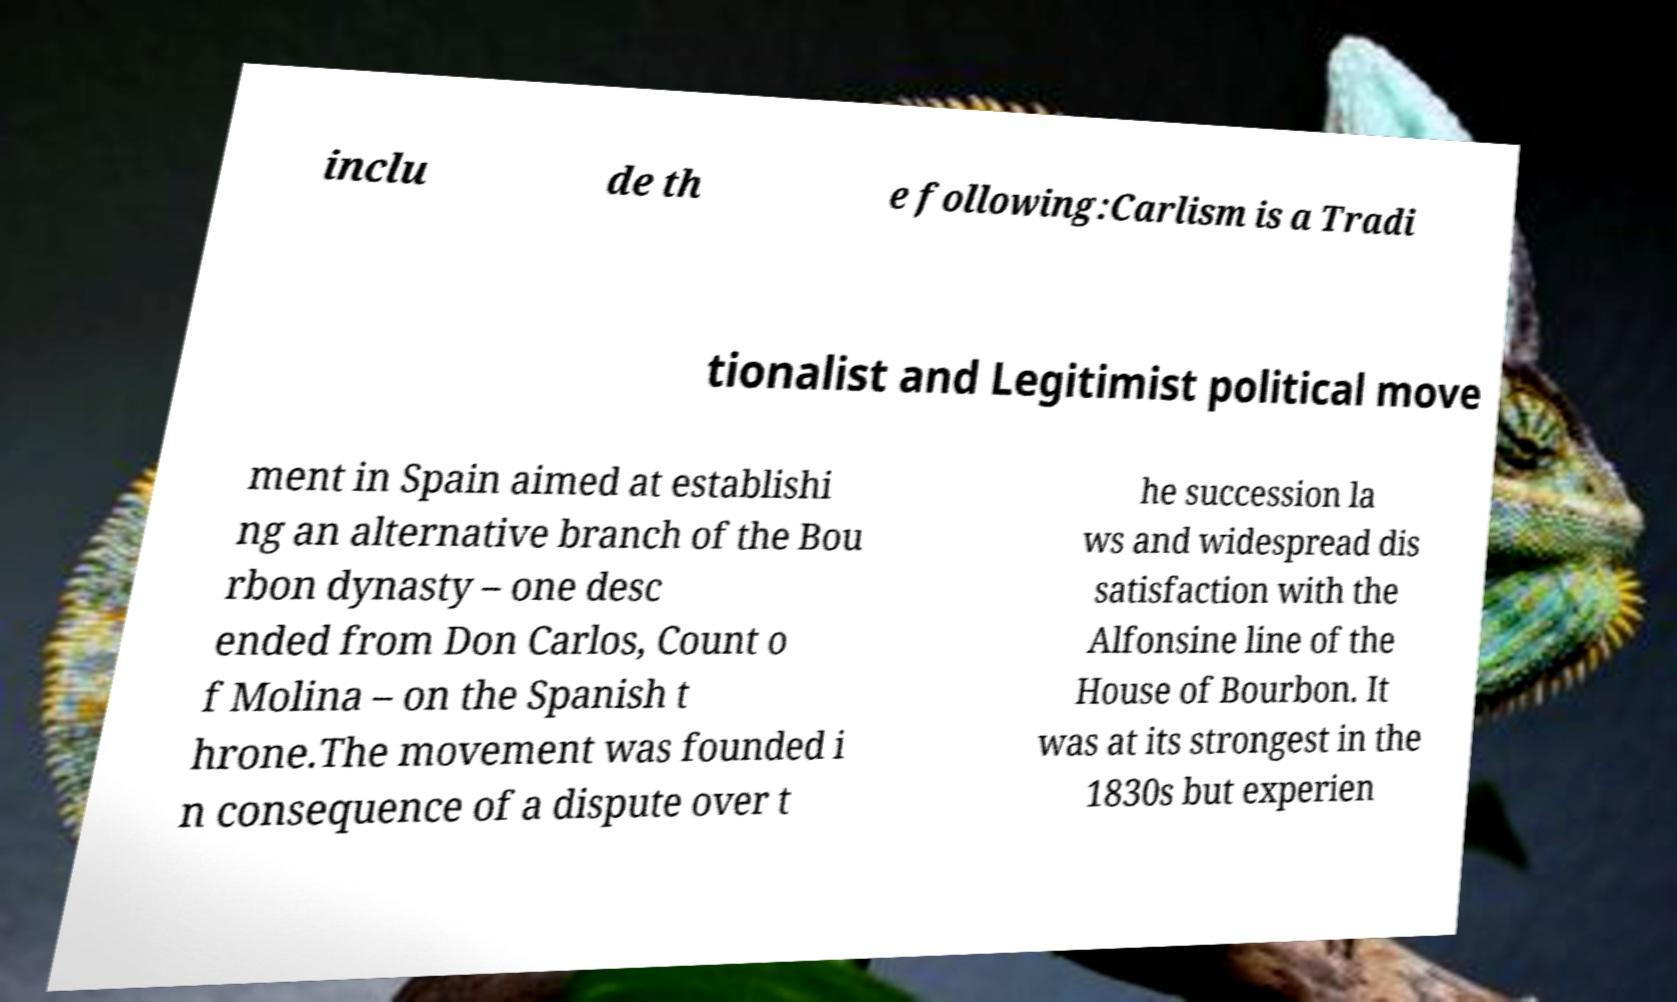Could you extract and type out the text from this image? inclu de th e following:Carlism is a Tradi tionalist and Legitimist political move ment in Spain aimed at establishi ng an alternative branch of the Bou rbon dynasty – one desc ended from Don Carlos, Count o f Molina – on the Spanish t hrone.The movement was founded i n consequence of a dispute over t he succession la ws and widespread dis satisfaction with the Alfonsine line of the House of Bourbon. It was at its strongest in the 1830s but experien 